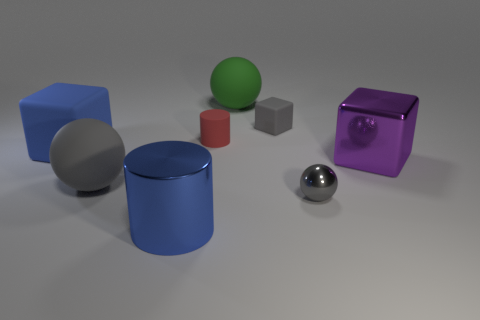Is the number of green things less than the number of yellow rubber cylinders?
Provide a short and direct response. No. Is the tiny red cylinder made of the same material as the blue cylinder?
Ensure brevity in your answer.  No. What number of other things are there of the same color as the metallic sphere?
Provide a succinct answer. 2. Are there more large red rubber objects than big gray rubber objects?
Your answer should be compact. No. Do the purple shiny object and the blue thing left of the blue metal object have the same size?
Ensure brevity in your answer.  Yes. What color is the matte object in front of the purple shiny object?
Ensure brevity in your answer.  Gray. What number of purple things are metal blocks or metal spheres?
Give a very brief answer. 1. What is the color of the metal block?
Offer a terse response. Purple. Is there any other thing that is the same material as the small gray cube?
Give a very brief answer. Yes. Are there fewer small gray balls on the left side of the green sphere than gray matte objects in front of the tiny rubber cube?
Give a very brief answer. Yes. 